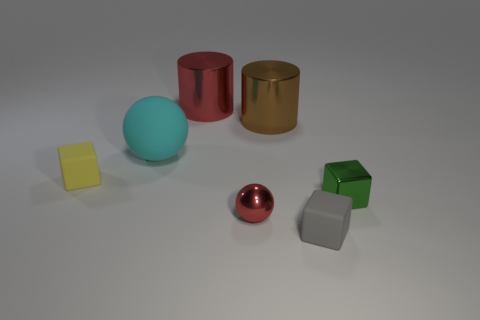There is a tiny red shiny object; are there any cylinders on the right side of it?
Make the answer very short. Yes. Are the cyan object and the tiny object that is on the left side of the matte sphere made of the same material?
Provide a short and direct response. Yes. Does the red object in front of the large brown object have the same shape as the yellow rubber thing?
Keep it short and to the point. No. How many big red cylinders have the same material as the yellow block?
Give a very brief answer. 0. What number of objects are either tiny matte cubes that are on the right side of the tiny yellow block or large red metal cylinders?
Offer a terse response. 2. The yellow rubber block has what size?
Make the answer very short. Small. What is the material of the small object that is to the right of the matte cube on the right side of the red cylinder?
Offer a very short reply. Metal. Does the metal cylinder in front of the red shiny cylinder have the same size as the small gray rubber object?
Make the answer very short. No. Are there any other small balls of the same color as the metal sphere?
Your answer should be very brief. No. What number of objects are either red things that are in front of the large rubber thing or red things in front of the large red metal object?
Provide a short and direct response. 1. 